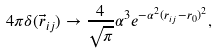Convert formula to latex. <formula><loc_0><loc_0><loc_500><loc_500>4 \pi \delta ( \vec { r } _ { i j } ) \to \frac { 4 } { \sqrt { \pi } } \alpha ^ { 3 } e ^ { - \alpha ^ { 2 } ( r _ { i j } - r _ { 0 } ) ^ { 2 } } ,</formula> 